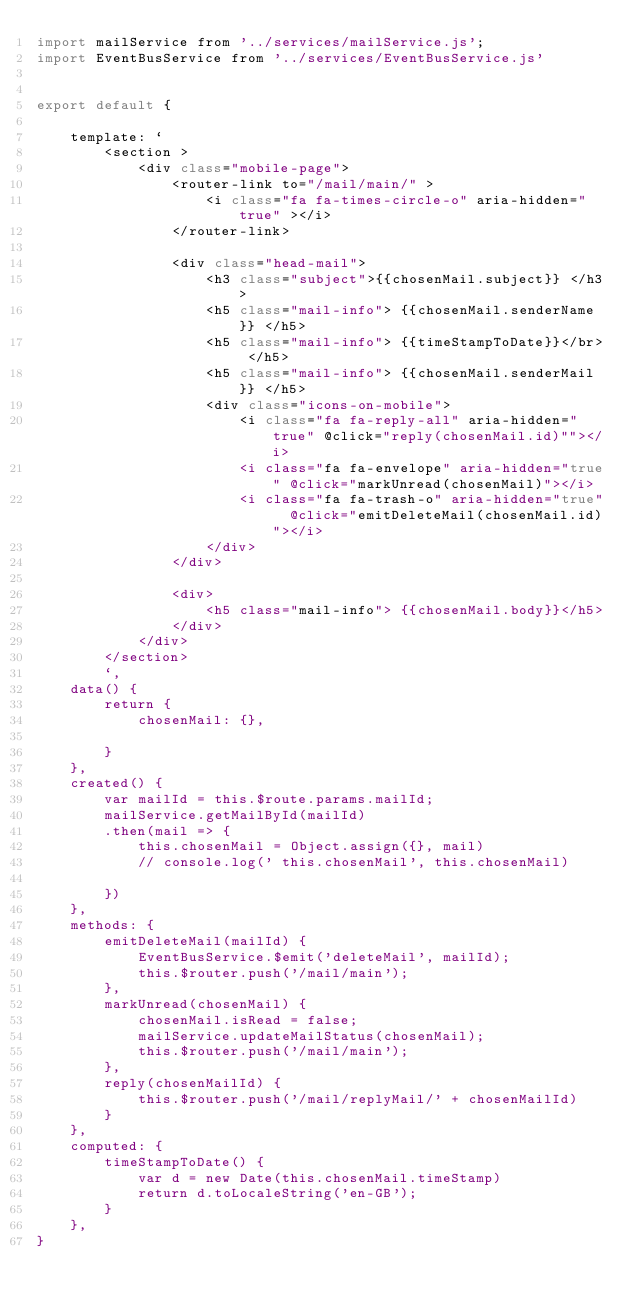<code> <loc_0><loc_0><loc_500><loc_500><_JavaScript_>import mailService from '../services/mailService.js';
import EventBusService from '../services/EventBusService.js'


export default {

    template: `
        <section >
            <div class="mobile-page">
                <router-link to="/mail/main/" > 
                    <i class="fa fa-times-circle-o" aria-hidden="true" ></i>
                </router-link>  
            
                <div class="head-mail">
                    <h3 class="subject">{{chosenMail.subject}} </h3>
                    <h5 class="mail-info"> {{chosenMail.senderName}} </h5>  
                    <h5 class="mail-info"> {{timeStampToDate}}</br> </h5>
                    <h5 class="mail-info"> {{chosenMail.senderMail}} </h5>
                    <div class="icons-on-mobile">
                        <i class="fa fa-reply-all" aria-hidden="true" @click="reply(chosenMail.id)""></i>
                        <i class="fa fa-envelope" aria-hidden="true" @click="markUnread(chosenMail)"></i>
                        <i class="fa fa-trash-o" aria-hidden="true"  @click="emitDeleteMail(chosenMail.id)"></i>
                    </div>
                </div>
            
                <div>
                    <h5 class="mail-info"> {{chosenMail.body}}</h5>  
                </div>
            </div>
        </section>
        `,
    data() {
        return {
            chosenMail: {},

        }
    },
    created() {
        var mailId = this.$route.params.mailId;
        mailService.getMailById(mailId)
        .then(mail => {
            this.chosenMail = Object.assign({}, mail)
            // console.log(' this.chosenMail', this.chosenMail)
           
        })     
    },
    methods: {
        emitDeleteMail(mailId) {
            EventBusService.$emit('deleteMail', mailId);
            this.$router.push('/mail/main');
        },
        markUnread(chosenMail) {
            chosenMail.isRead = false;
            mailService.updateMailStatus(chosenMail);
            this.$router.push('/mail/main');
        },
        reply(chosenMailId) {
            this.$router.push('/mail/replyMail/' + chosenMailId)
        }
    },
    computed: {
        timeStampToDate() {
            var d = new Date(this.chosenMail.timeStamp)
            return d.toLocaleString('en-GB');
        }
    },
}

</code> 